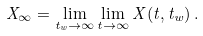<formula> <loc_0><loc_0><loc_500><loc_500>X _ { \infty } = \lim _ { t _ { w } \rightarrow \infty } \lim _ { t \rightarrow \infty } X ( t , t _ { w } ) \, .</formula> 